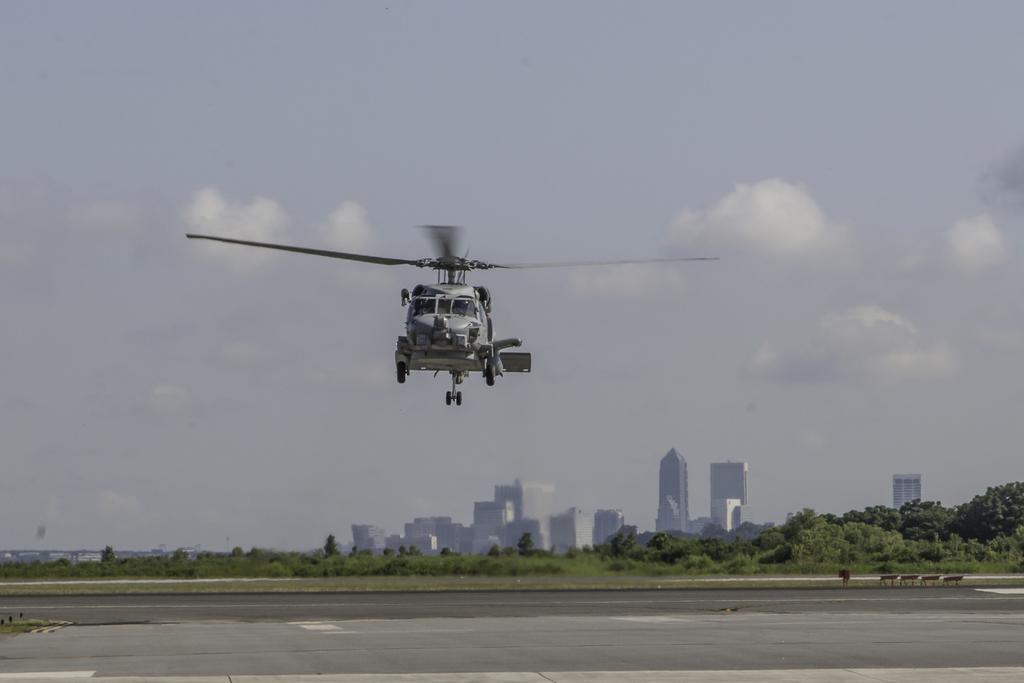Could you give a brief overview of what you see in this image? In this image we can see a helicopter flying in the air. Here we can see road, plants, trees, buildings, and objects. In the background there is sky with clouds. 